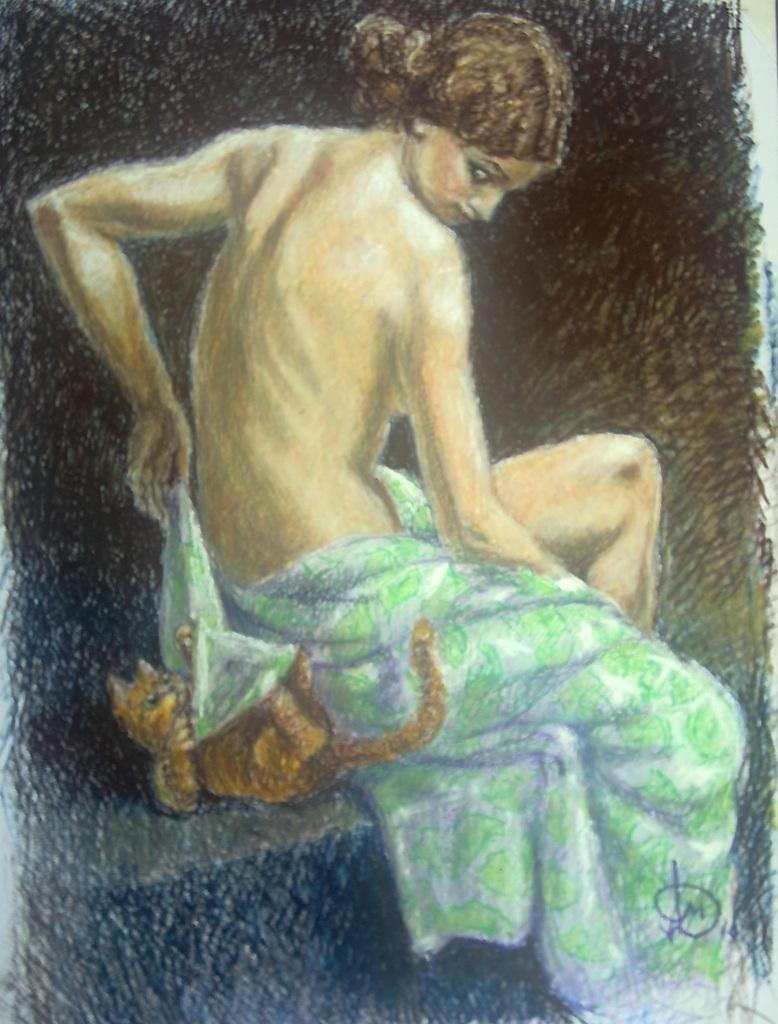What is the main subject of the image? The main subject of the image is a painting. Can you describe the scene depicted in the painting? There is a lady in the center of the painting, and there is also a cat present. How many nerves can be seen in the painting? There are no nerves depicted in the painting; it features a lady and a cat. What type of animal is present in the painting besides the cat? There are no other animals besides the cat depicted in the painting. 